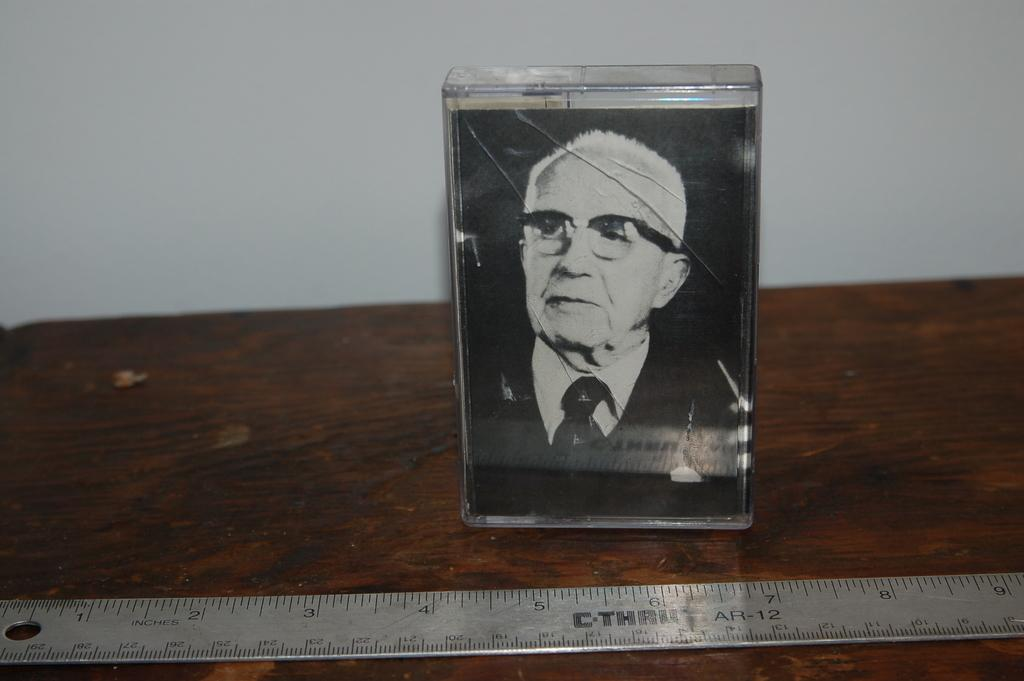What object is on the table in the image? There is a small glass box on the table. What is inside the glass box? The glass box contains a picture of a man. What other object is near the glass box? There is a scale beside the glass box. What can be seen in the background of the image? There is a wall in the background of the image. Is your mom crying in the image? There is no person, including your mom, present in the image. The image only features a glass box containing a picture of a man, a scale, and a wall in the background. 